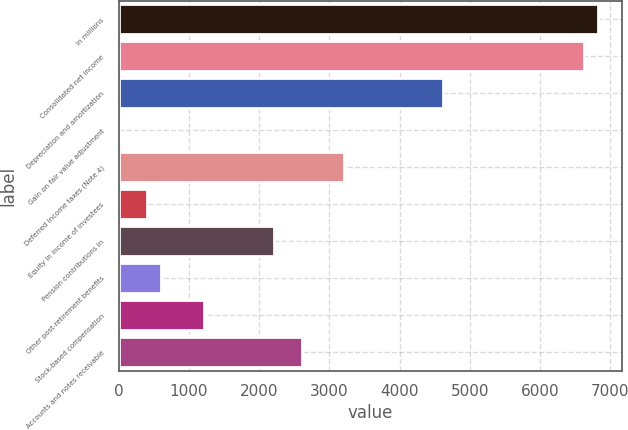<chart> <loc_0><loc_0><loc_500><loc_500><bar_chart><fcel>In millions<fcel>Consolidated net income<fcel>Depreciation and amortization<fcel>Gain on fair value adjustment<fcel>Deferred income taxes (Note 4)<fcel>Equity in income of investees<fcel>Pension contributions in<fcel>Other post-retirement benefits<fcel>Stock-based compensation<fcel>Accounts and notes receivable<nl><fcel>6824<fcel>6623.5<fcel>4618.5<fcel>7<fcel>3215<fcel>408<fcel>2212.5<fcel>608.5<fcel>1210<fcel>2613.5<nl></chart> 